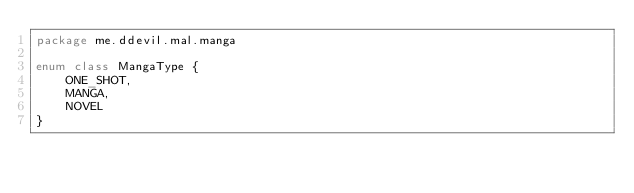Convert code to text. <code><loc_0><loc_0><loc_500><loc_500><_Kotlin_>package me.ddevil.mal.manga

enum class MangaType {
    ONE_SHOT,
    MANGA,
    NOVEL
}</code> 